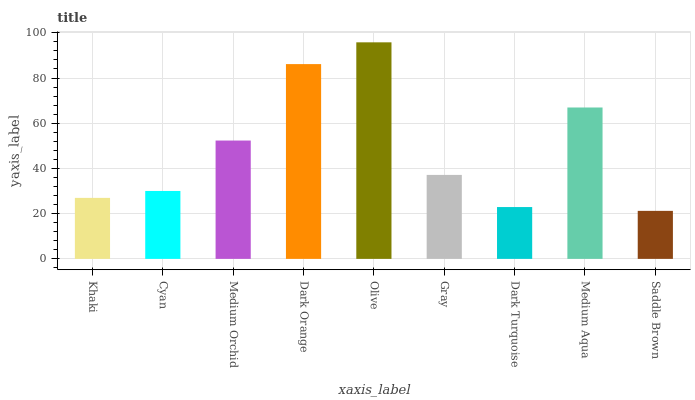Is Saddle Brown the minimum?
Answer yes or no. Yes. Is Olive the maximum?
Answer yes or no. Yes. Is Cyan the minimum?
Answer yes or no. No. Is Cyan the maximum?
Answer yes or no. No. Is Cyan greater than Khaki?
Answer yes or no. Yes. Is Khaki less than Cyan?
Answer yes or no. Yes. Is Khaki greater than Cyan?
Answer yes or no. No. Is Cyan less than Khaki?
Answer yes or no. No. Is Gray the high median?
Answer yes or no. Yes. Is Gray the low median?
Answer yes or no. Yes. Is Cyan the high median?
Answer yes or no. No. Is Olive the low median?
Answer yes or no. No. 